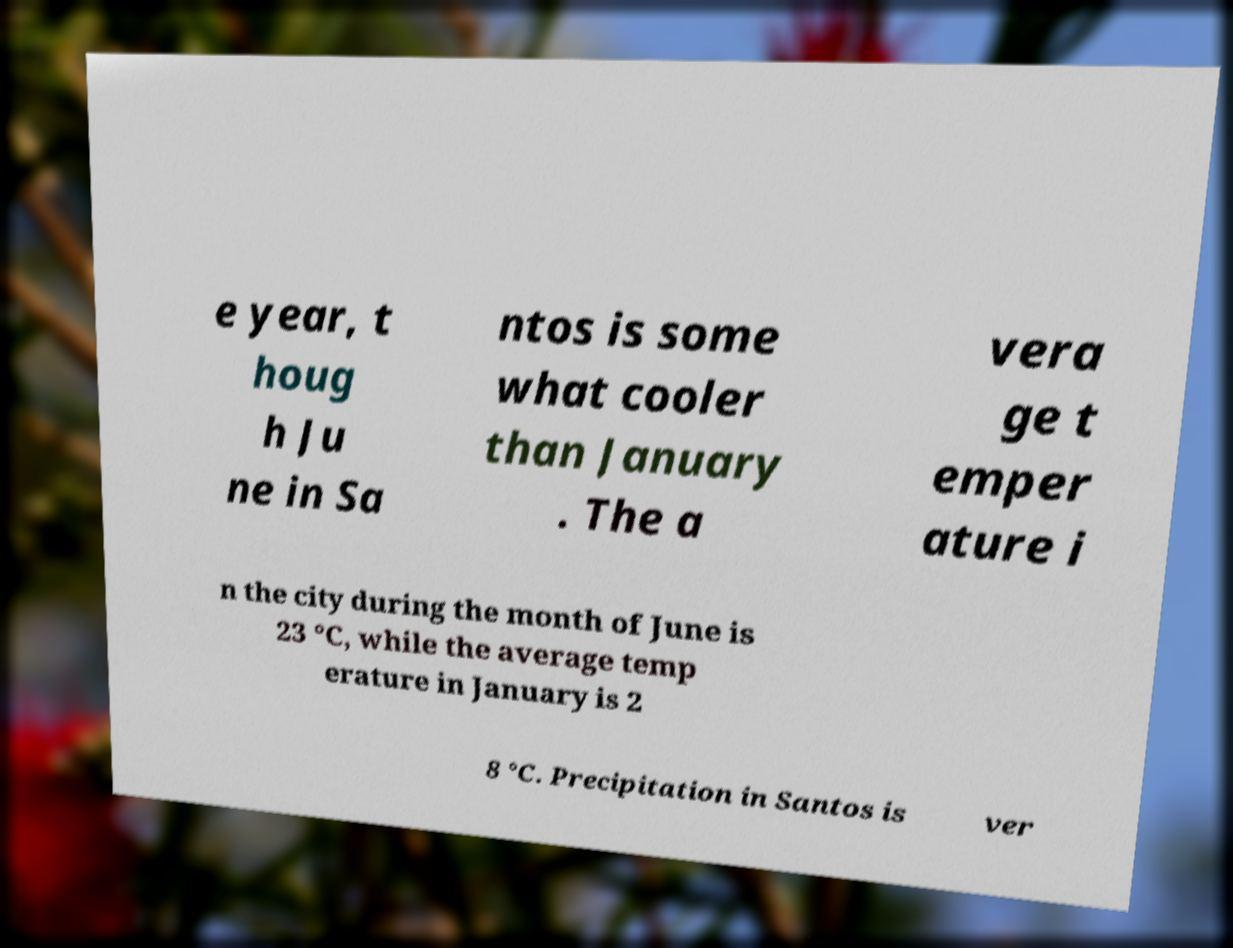Please read and relay the text visible in this image. What does it say? e year, t houg h Ju ne in Sa ntos is some what cooler than January . The a vera ge t emper ature i n the city during the month of June is 23 °C, while the average temp erature in January is 2 8 °C. Precipitation in Santos is ver 